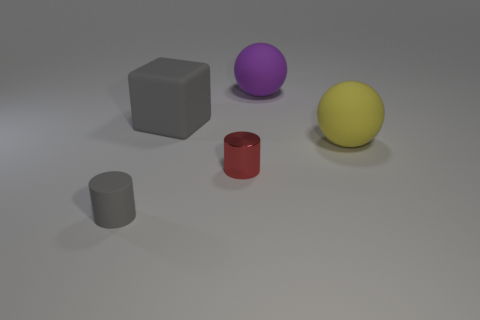Do the gray thing that is behind the red metal object and the matte sphere that is right of the purple ball have the same size?
Your response must be concise. Yes. There is a small object that is the same material as the yellow ball; what is its shape?
Make the answer very short. Cylinder. Are there any other things that are the same shape as the small red object?
Provide a succinct answer. Yes. There is a tiny rubber cylinder on the left side of the object that is behind the gray matte object behind the yellow rubber sphere; what color is it?
Offer a very short reply. Gray. Is the number of big yellow matte spheres in front of the big yellow rubber object less than the number of small metallic cylinders behind the tiny metallic object?
Offer a very short reply. No. Is the big purple rubber object the same shape as the small red shiny thing?
Keep it short and to the point. No. How many other balls have the same size as the yellow matte ball?
Offer a terse response. 1. Is the number of big yellow rubber things in front of the gray rubber cylinder less than the number of large yellow rubber balls?
Provide a succinct answer. Yes. There is a rubber thing to the right of the big rubber sphere behind the block; what size is it?
Offer a terse response. Large. How many objects are either rubber balls or large gray rubber cubes?
Provide a succinct answer. 3. 